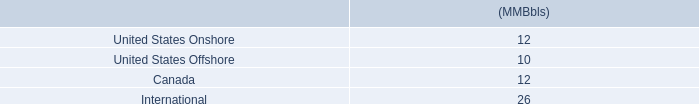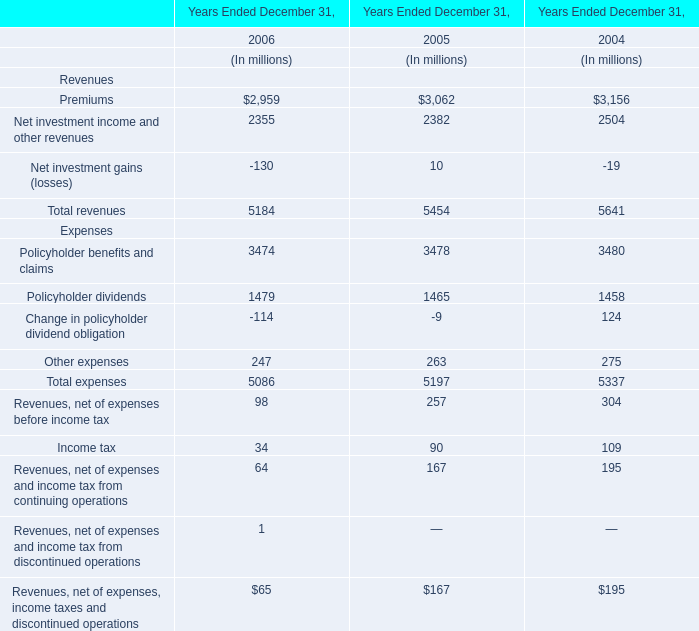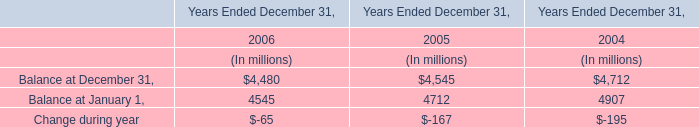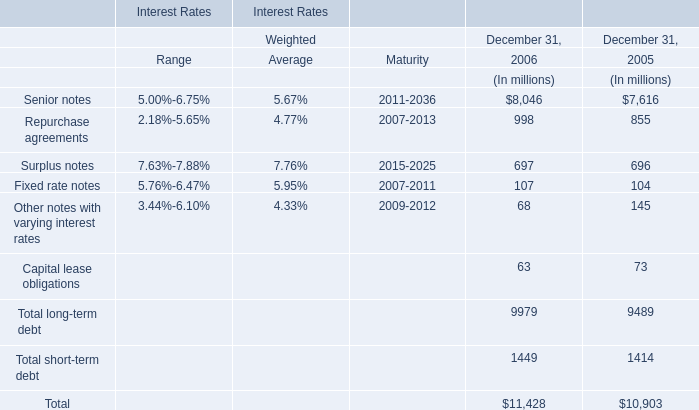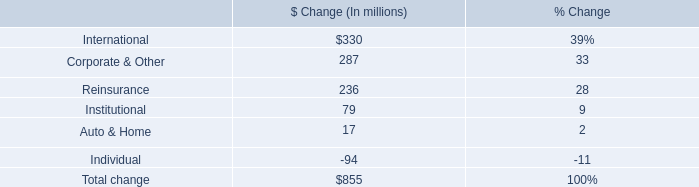What is the sum of the Fixed rate notes in the years where Surplus notes is positive? (in million) 
Computations: (107 + 104)
Answer: 211.0. 